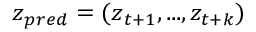Convert formula to latex. <formula><loc_0><loc_0><loc_500><loc_500>z _ { p r e d } = ( z _ { t + 1 } , \dots , z _ { t + k } )</formula> 